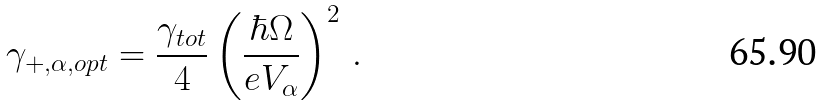<formula> <loc_0><loc_0><loc_500><loc_500>\gamma _ { + , \alpha , o p t } = \frac { \gamma _ { t o t } } { 4 } \left ( \frac { \hbar { \Omega } } { e V _ { \alpha } } \right ) ^ { 2 } \, .</formula> 